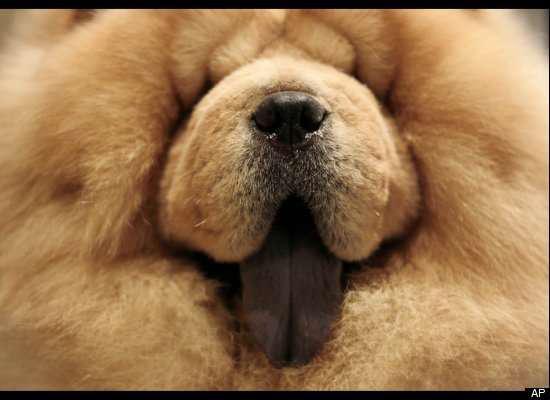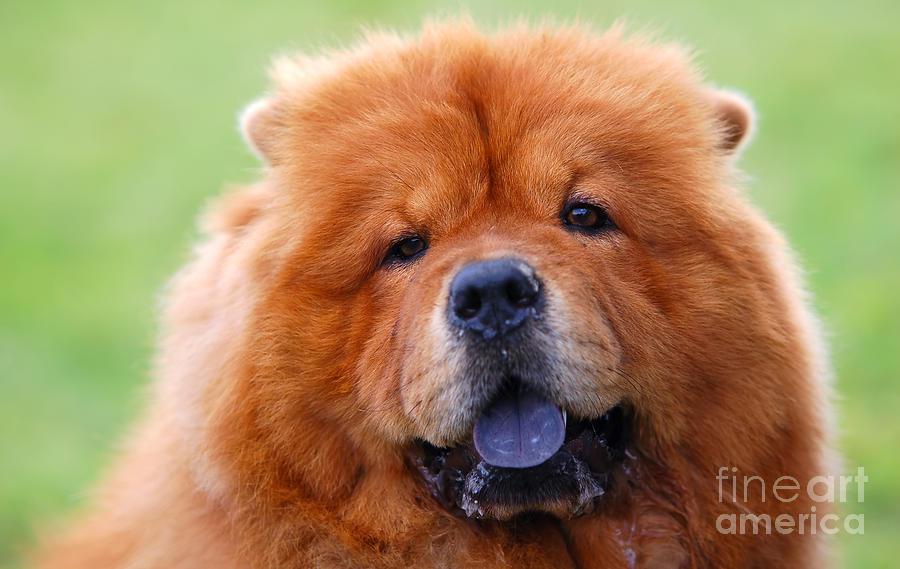The first image is the image on the left, the second image is the image on the right. Given the left and right images, does the statement "Two dog tongues are visible" hold true? Answer yes or no. Yes. 